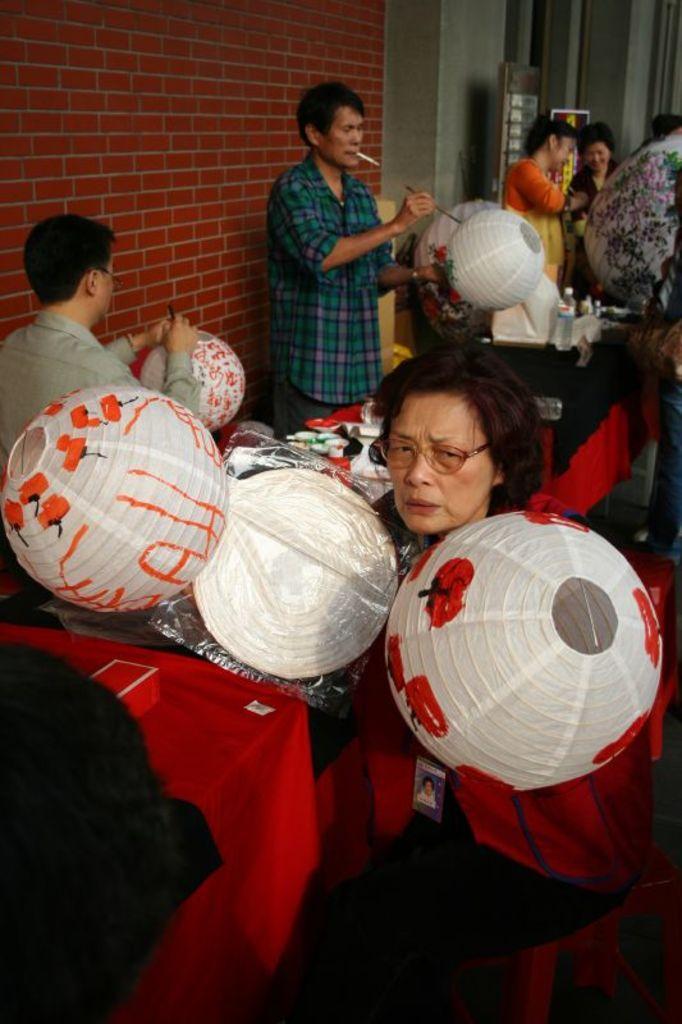Describe this image in one or two sentences. This image consists of many people. They are holding balloons. At the bottom, there is a table covered with red cloth. In the background, there is a wall. 